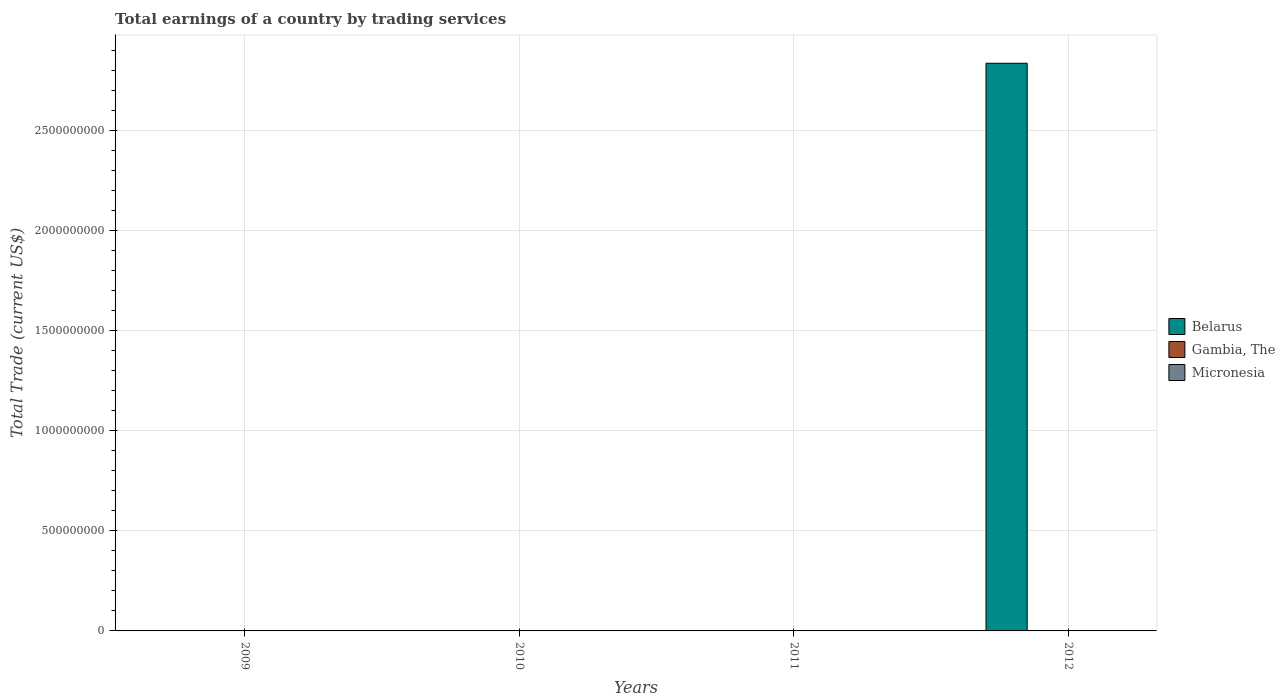Are the number of bars per tick equal to the number of legend labels?
Provide a short and direct response. No. Are the number of bars on each tick of the X-axis equal?
Your response must be concise. No. How many bars are there on the 4th tick from the left?
Provide a succinct answer. 1. What is the label of the 1st group of bars from the left?
Offer a terse response. 2009. What is the total earnings in Micronesia in 2012?
Give a very brief answer. 0. Across all years, what is the maximum total earnings in Belarus?
Keep it short and to the point. 2.83e+09. Across all years, what is the minimum total earnings in Gambia, The?
Ensure brevity in your answer.  0. What is the average total earnings in Belarus per year?
Your answer should be compact. 7.08e+08. What is the difference between the highest and the lowest total earnings in Belarus?
Ensure brevity in your answer.  2.83e+09. In how many years, is the total earnings in Gambia, The greater than the average total earnings in Gambia, The taken over all years?
Give a very brief answer. 0. Is it the case that in every year, the sum of the total earnings in Micronesia and total earnings in Gambia, The is greater than the total earnings in Belarus?
Offer a very short reply. No. How many bars are there?
Provide a succinct answer. 1. Does the graph contain any zero values?
Keep it short and to the point. Yes. Does the graph contain grids?
Provide a succinct answer. Yes. How many legend labels are there?
Ensure brevity in your answer.  3. How are the legend labels stacked?
Provide a succinct answer. Vertical. What is the title of the graph?
Your answer should be very brief. Total earnings of a country by trading services. What is the label or title of the X-axis?
Give a very brief answer. Years. What is the label or title of the Y-axis?
Your answer should be very brief. Total Trade (current US$). What is the Total Trade (current US$) of Micronesia in 2010?
Keep it short and to the point. 0. What is the Total Trade (current US$) of Gambia, The in 2011?
Offer a very short reply. 0. What is the Total Trade (current US$) of Micronesia in 2011?
Your answer should be very brief. 0. What is the Total Trade (current US$) in Belarus in 2012?
Ensure brevity in your answer.  2.83e+09. What is the Total Trade (current US$) in Gambia, The in 2012?
Ensure brevity in your answer.  0. What is the Total Trade (current US$) in Micronesia in 2012?
Offer a terse response. 0. Across all years, what is the maximum Total Trade (current US$) of Belarus?
Make the answer very short. 2.83e+09. What is the total Total Trade (current US$) of Belarus in the graph?
Provide a succinct answer. 2.83e+09. What is the total Total Trade (current US$) in Gambia, The in the graph?
Give a very brief answer. 0. What is the average Total Trade (current US$) of Belarus per year?
Keep it short and to the point. 7.08e+08. What is the average Total Trade (current US$) in Gambia, The per year?
Your response must be concise. 0. What is the average Total Trade (current US$) of Micronesia per year?
Keep it short and to the point. 0. What is the difference between the highest and the lowest Total Trade (current US$) in Belarus?
Provide a short and direct response. 2.83e+09. 